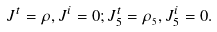<formula> <loc_0><loc_0><loc_500><loc_500>J ^ { t } = \rho , J ^ { i } = 0 ; J _ { 5 } ^ { t } = \rho _ { _ { 5 } } , J _ { 5 } ^ { i } = 0 .</formula> 